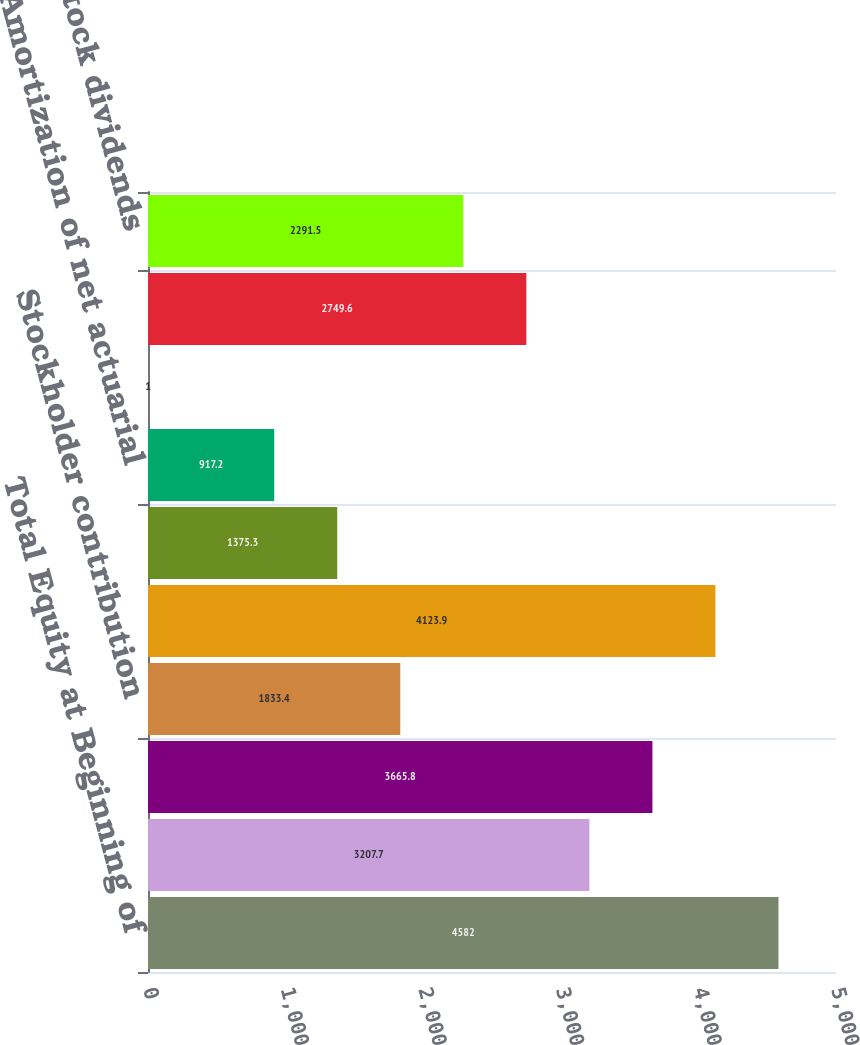<chart> <loc_0><loc_0><loc_500><loc_500><bar_chart><fcel>Total Equity at Beginning of<fcel>At beginning and end of period<fcel>At beginning of period<fcel>Stockholder contribution<fcel>At end of period<fcel>Net gain (loss) arising during<fcel>Amortization of net actuarial<fcel>Unrealized gain on investments<fcel>Net income<fcel>Common stock dividends<nl><fcel>4582<fcel>3207.7<fcel>3665.8<fcel>1833.4<fcel>4123.9<fcel>1375.3<fcel>917.2<fcel>1<fcel>2749.6<fcel>2291.5<nl></chart> 